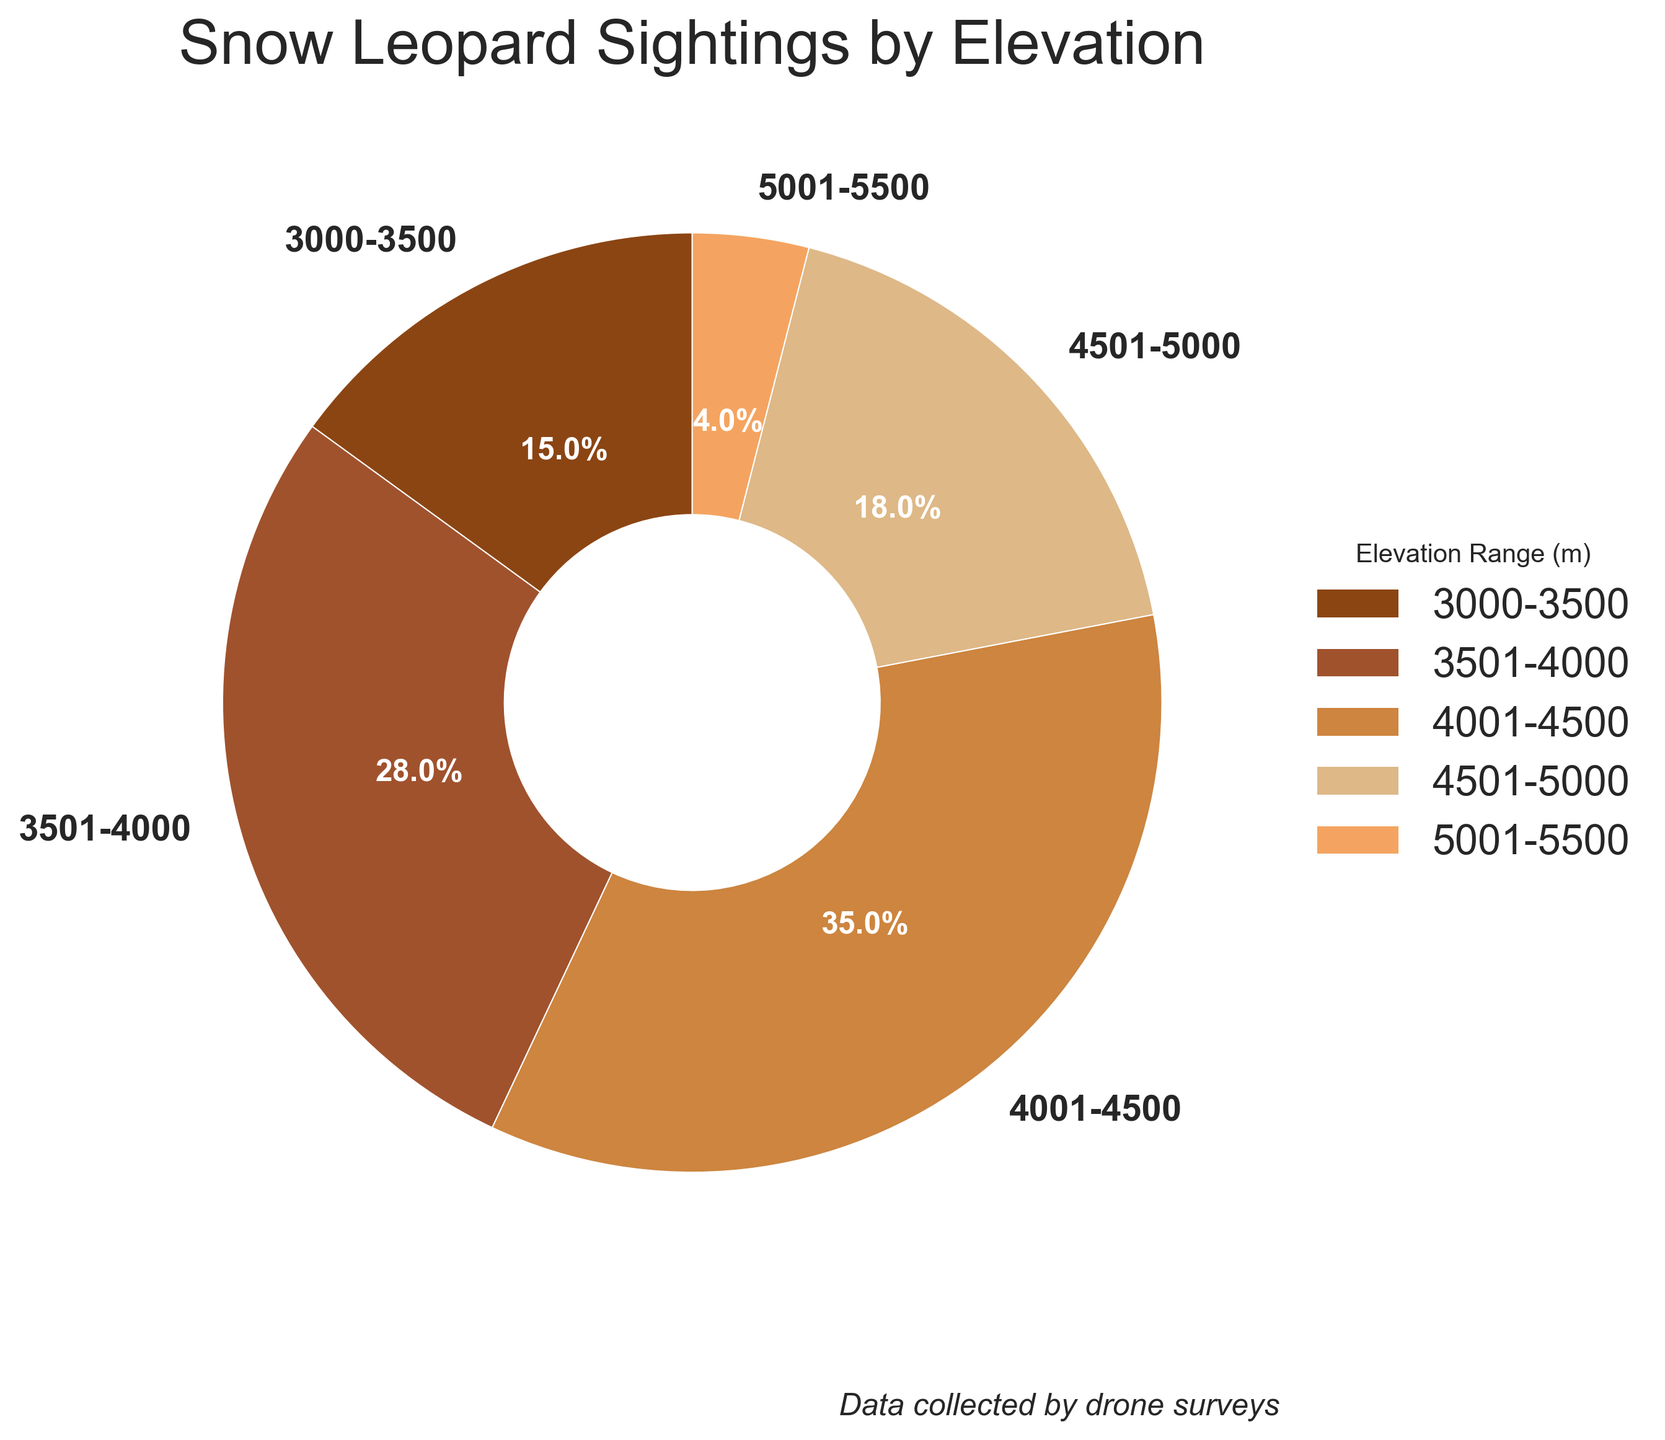What percentage of snow leopard sightings were reported in the 4001-4500 m range? Locate the segment labeled '4001-4500' in the pie chart and read the percentage value associated with it, which is 35%.
Answer: 35% Which elevation range had the fewest snow leopard sightings? Determine which slice of the pie chart is the smallest. The chart indicates that the 5001-5500 m elevation range has the smallest percentage of sightings, at 4%.
Answer: 5001-5500 How do the proportions of sightings in the 3000-3500 m and 4501-5000 m ranges compare? Compare the percentages for both ranges from the pie chart: 3000-3500 m is 15%, and 4501-5000 m is 18%. 18% is greater than 15%.
Answer: 4501-5000 > 3000-3500 What is the total percentage of sightings that occurred below 4000 m? Add the percentages for the 3000-3500 m and 3501-4000 m ranges: 15% + 28% = 43%.
Answer: 43% Calculate the combined percentage of sightings in the 4001-4500 m and 4501-5000 m ranges. Sum the percentages for 4001-4500 m (35%) and 4501-5000 m (18%) to get the total: 35% + 18% = 53%.
Answer: 53% Between which two adjacent elevation ranges is the difference in sightings the greatest? Calculate the differences between segment percentages for adjacent ranges: 4501-5000 m (18%) and 4001-4500 m (35%) have the highest difference of 35% - 18% = 17%.
Answer: 4001-4500 and 4501-5000 Which color represents the elevation range with the highest sightings? Identify the largest pie segment and its color. The '4001-4500' range has the highest sightings at 35% and is represented by the color 'dark tan' (#CD853F).
Answer: dark tan What is the average percentage of sightings across all elevation ranges? Sum the percentages of all five segments and divide by the number of segments: (15% + 28% + 35% + 18% + 4%) / 5 = 100% / 5 = 20%.
Answer: 20% If you were to combine the sightings from 3000-3500 m and 5001-5500 m, what percentage would that be, and would it be greater than the sightings in the 4501-5000 m range? Add the percentages of 3000-3500 m (15%) and 5001-5500 m (4%) to get 19%. Compare it to 4501-5000 m: 19% is greater than 18%.
Answer: 19%, Yes 